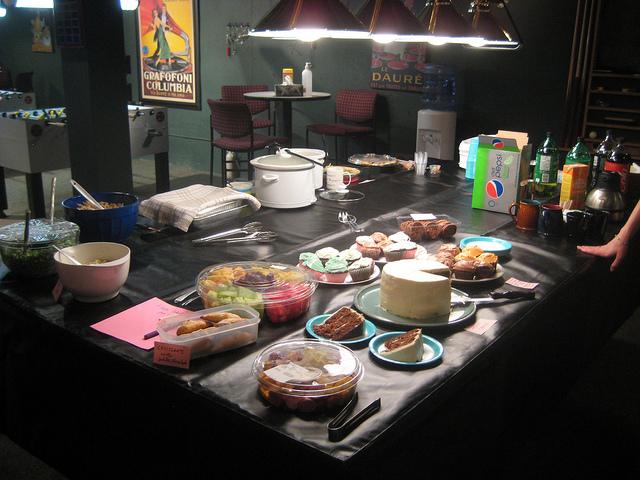What color is the paper on the table?
Keep it brief. Pink. How many cakes are on the table?
Be succinct. 1. How many chairs in the background?
Short answer required. 3. How many tiers is the cupcake holder?
Give a very brief answer. 1. What color is the icing on the cake?
Short answer required. White. 